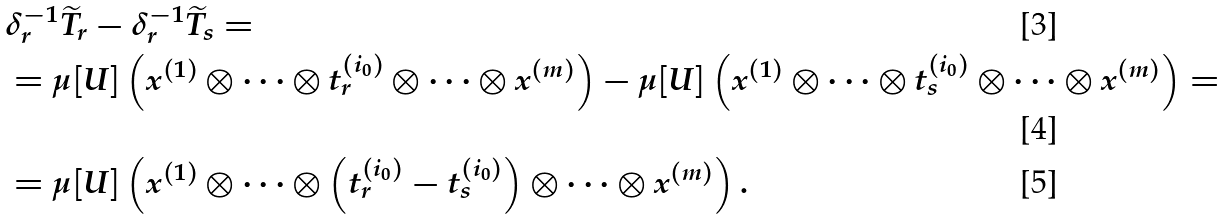<formula> <loc_0><loc_0><loc_500><loc_500>& \delta _ { r } ^ { - 1 } \widetilde { T } _ { r } - \delta _ { r } ^ { - 1 } \widetilde { T } _ { s } = \\ & = \mu [ U ] \left ( x ^ { ( 1 ) } \otimes \dots \otimes t ^ { ( i _ { 0 } ) } _ { r } \otimes \dots \otimes x ^ { ( m ) } \right ) - \mu [ U ] \left ( x ^ { ( 1 ) } \otimes \dots \otimes t ^ { ( i _ { 0 } ) } _ { s } \otimes \dots \otimes x ^ { ( m ) } \right ) = \\ & = \mu [ U ] \left ( x ^ { ( 1 ) } \otimes \dots \otimes \left ( t ^ { ( i _ { 0 } ) } _ { r } - t ^ { ( i _ { 0 } ) } _ { s } \right ) \otimes \dots \otimes x ^ { ( m ) } \right ) .</formula> 